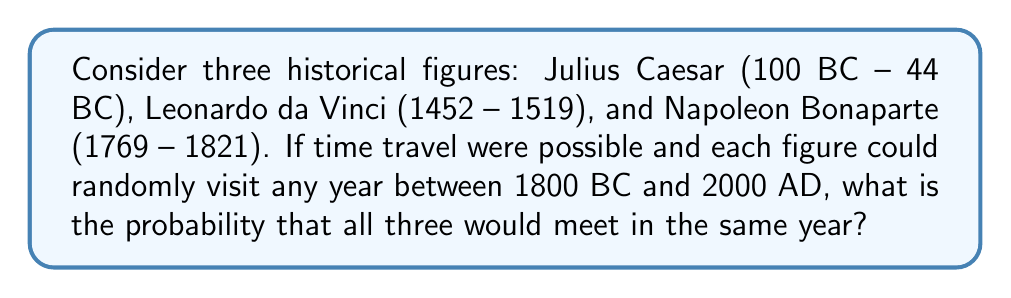Could you help me with this problem? Let's approach this step-by-step:

1) First, we need to calculate the total number of years in the given range:
   $$(2000 + 1800) = 3800 \text{ years}$$

2) For all three figures to meet, they must all choose the same year. The probability of this happening is the same as the probability of all three choosing any specific year.

3) For each historical figure, the probability of choosing any specific year is:
   $$P(\text{choosing a specific year}) = \frac{1}{3800}$$

4) For all three to choose the same year, we multiply these probabilities:
   $$P(\text{all three choose the same year}) = \frac{1}{3800} \times \frac{1}{3800} \times \frac{1}{3800}$$

5) Simplifying:
   $$P(\text{all three meet}) = \frac{1}{3800^3} = \frac{1}{54,872,000,000}$$

Therefore, the probability of all three historical figures meeting in the same year is $\frac{1}{54,872,000,000}$ or approximately $1.82 \times 10^{-11}$.
Answer: $\frac{1}{54,872,000,000}$ 